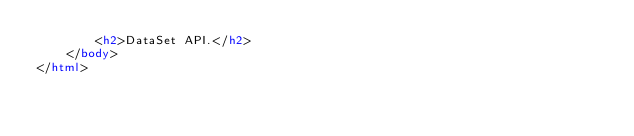<code> <loc_0><loc_0><loc_500><loc_500><_HTML_>        <h2>DataSet API.</h2>
    </body>
</html>
</code> 